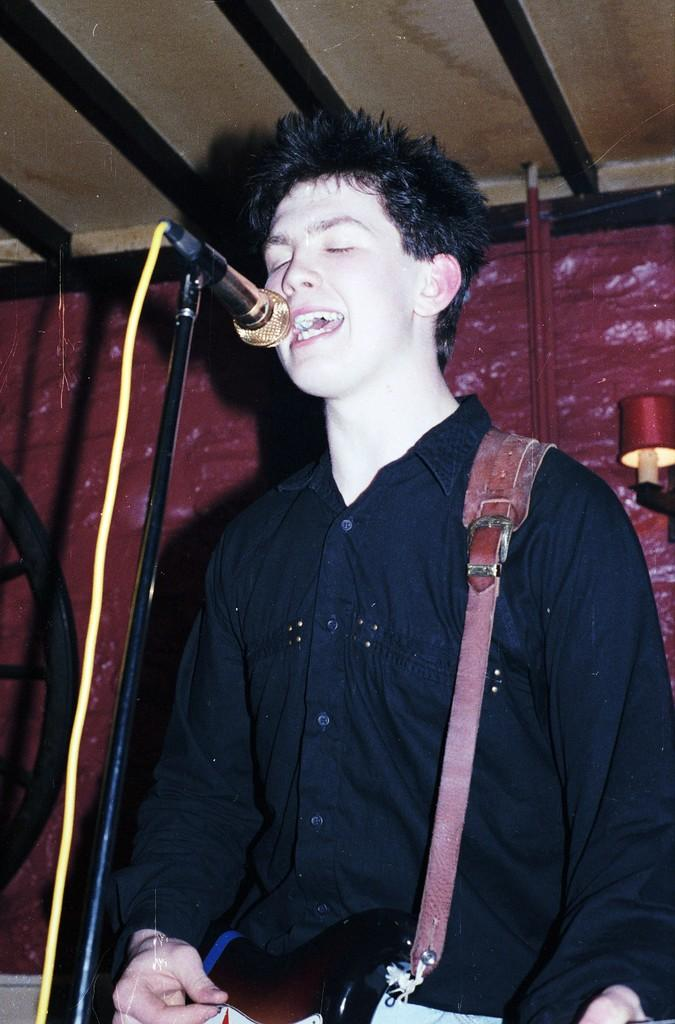What is the main subject of the image? The main subject of the image is a man. What is the man doing in the image? The man is singing in the image. What object is the man holding while singing? The man is holding a microphone (mike) in the image. What type of clouds can be seen in the background of the image? There is no background or clouds visible in the image, as it only features a man singing while holding a microphone. 